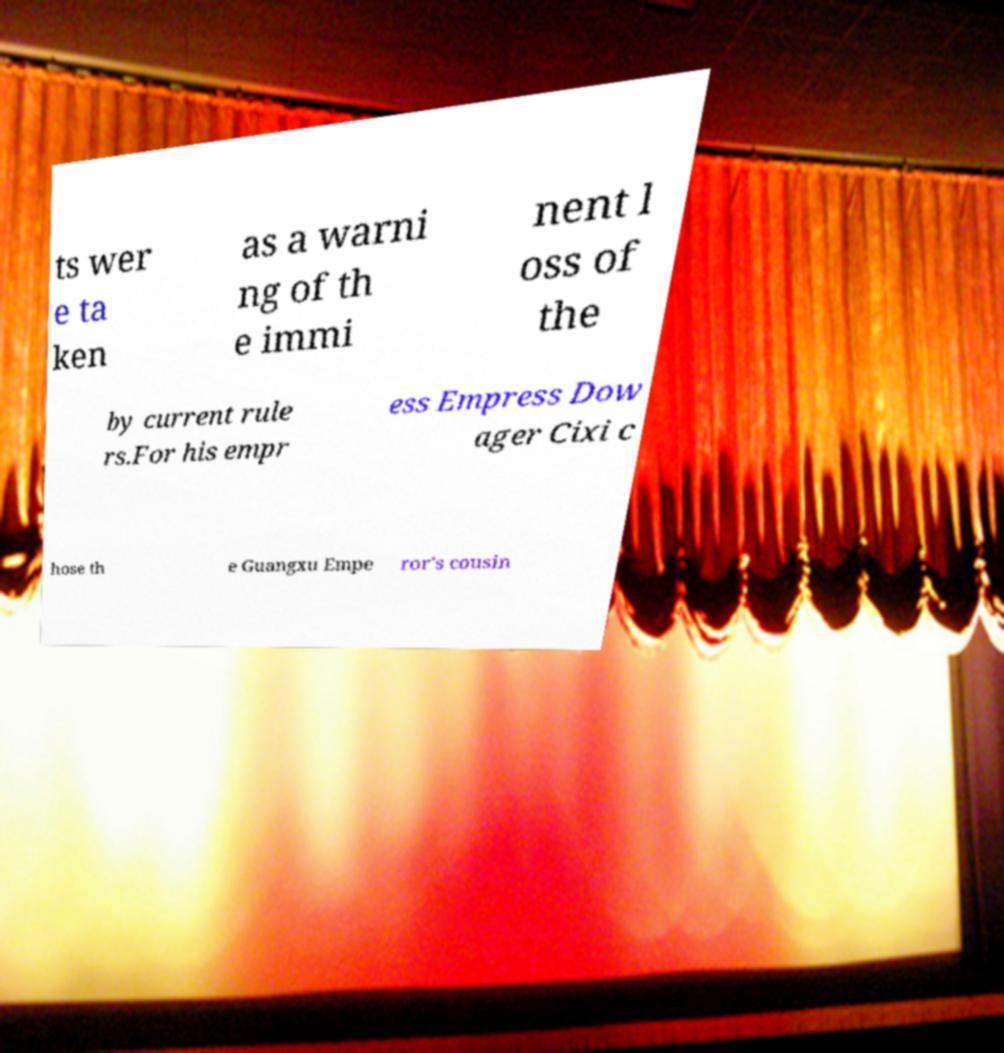I need the written content from this picture converted into text. Can you do that? ts wer e ta ken as a warni ng of th e immi nent l oss of the by current rule rs.For his empr ess Empress Dow ager Cixi c hose th e Guangxu Empe ror's cousin 